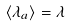<formula> <loc_0><loc_0><loc_500><loc_500>\langle { \lambda _ { a } } \rangle = \lambda</formula> 